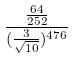<formula> <loc_0><loc_0><loc_500><loc_500>\frac { \frac { 6 4 } { 2 5 2 } } { ( \frac { 3 } { \sqrt { 1 0 } } ) ^ { 4 7 6 } }</formula> 